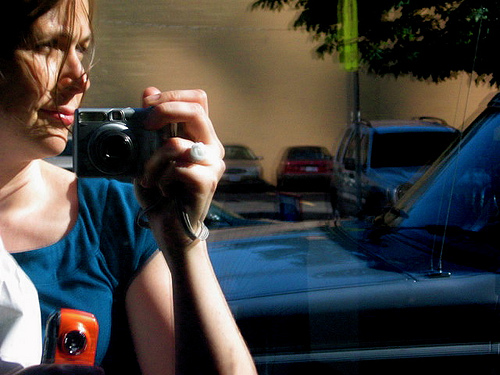What can be done using the orange thing?
A. eat food
B. take pictures
C. fly around
D. lock house
Answer with the option's letter from the given choices directly. B. The orange object in question appears to be a camera, which is a device primarily used to take pictures, capturing moments as still images to preserve memories, tell stories, and communicate visually. 